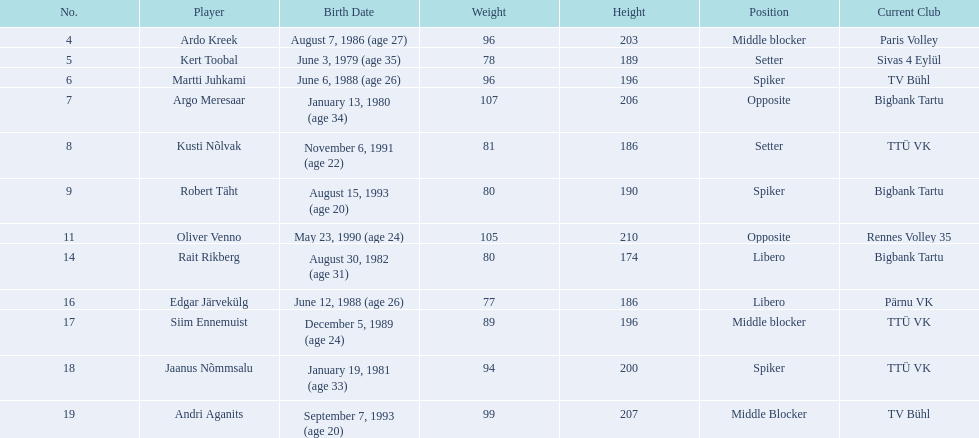What are the heights in centimeters of the male team members? 203, 189, 196, 206, 186, 190, 210, 174, 186, 196, 200, 207. Who has the highest height among the team members? 210. Which player has a height of 210 cm? Oliver Venno. 